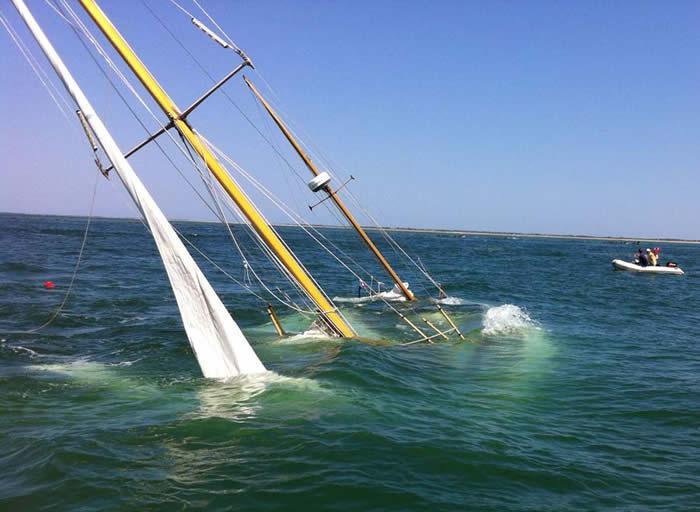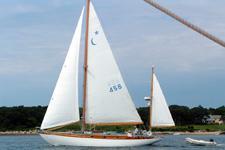The first image is the image on the left, the second image is the image on the right. Evaluate the accuracy of this statement regarding the images: "There are multiple boats sailing in the left image.". Is it true? Answer yes or no. No. The first image is the image on the left, the second image is the image on the right. Evaluate the accuracy of this statement regarding the images: "In the left image, there are two boats, regardless of buoyancy.". Is it true? Answer yes or no. Yes. 